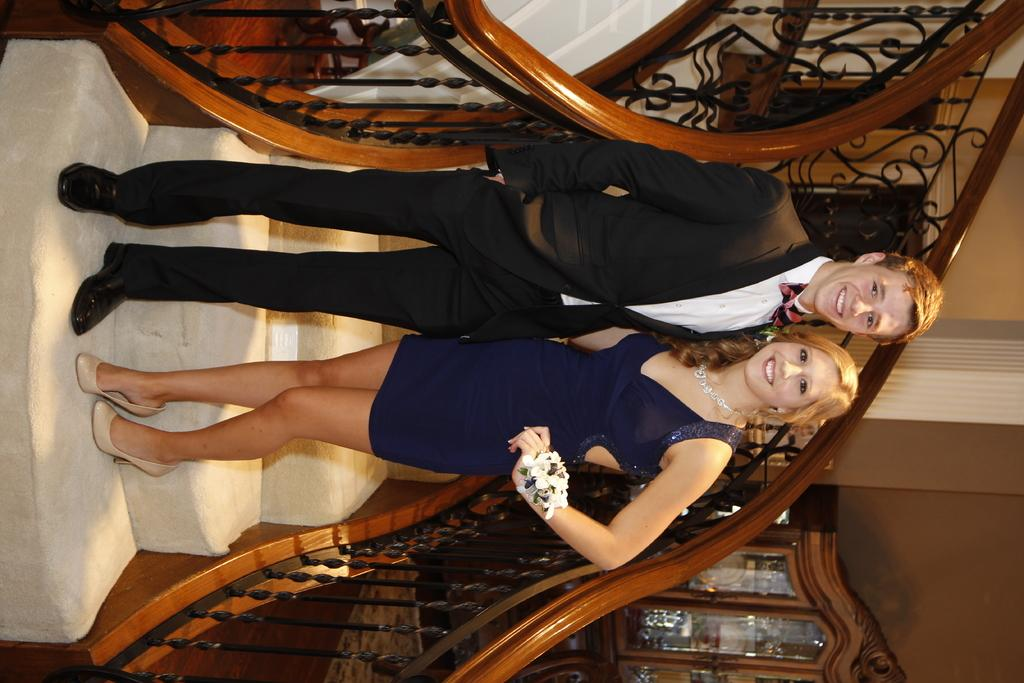Who is present in the image? There is a couple in the image. Where are the couple standing? The couple is standing on the stairs. What is located beside the stairs? There is a cupboard beside the stairs. What can be seen in the background of the image? There is a wall in the background of the image. What type of space suit is the lawyer wearing in the image? There is no lawyer or space suit present in the image. 